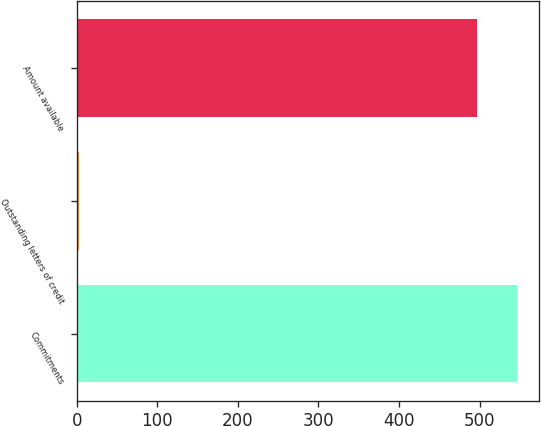Convert chart to OTSL. <chart><loc_0><loc_0><loc_500><loc_500><bar_chart><fcel>Commitments<fcel>Outstanding letters of credit<fcel>Amount available<nl><fcel>546.7<fcel>3<fcel>497<nl></chart> 